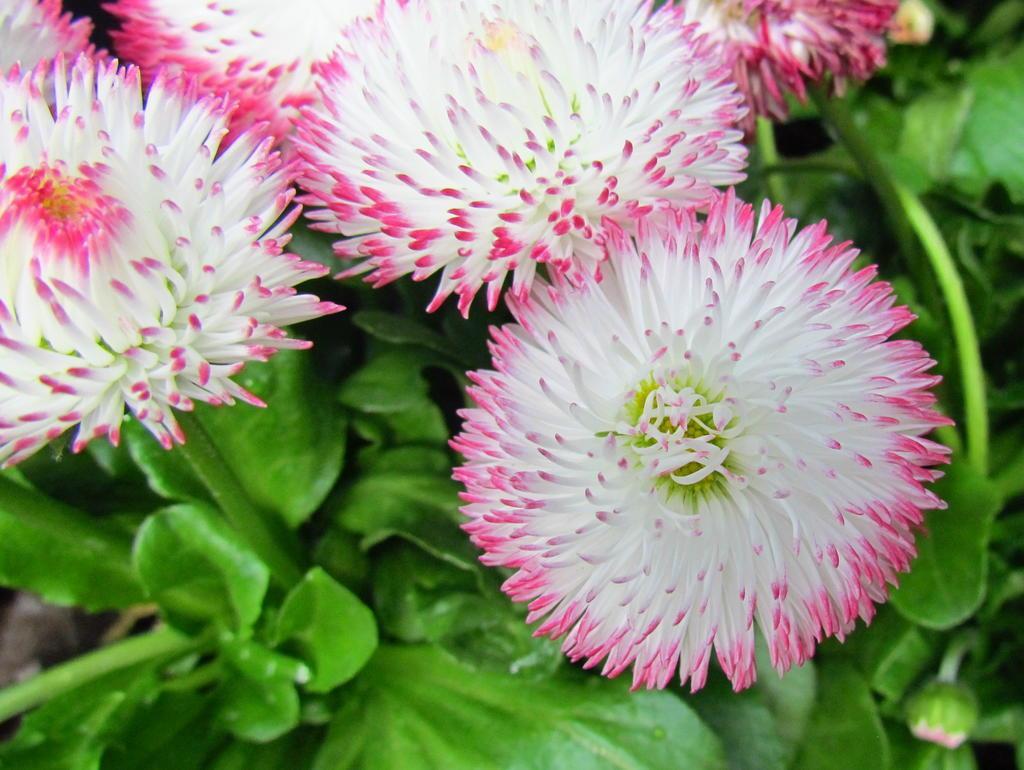How would you summarize this image in a sentence or two? In this picture there are flowers and there is a bud on the plant and the flowers are in white and pink color. 